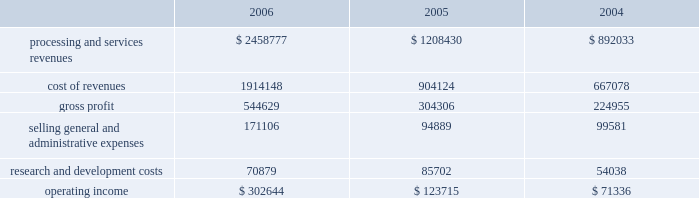Higher average borrowings .
Additionally , the recapitalization that occurred late in the first quarter of 2005 resulted in a full year of interest in 2006 as compared to approximately ten months in 2005 .
The increase in interest expense in 2005 as compared to 2004 also resulted from the recapitalization in 2005 .
Income tax expense income tax expense totaled $ 150.2 million , $ 116.1 million and $ 118.3 million for 2006 , 2005 and 2004 , respectively .
This resulted in an effective tax rate of 37.2% ( 37.2 % ) , 37.2% ( 37.2 % ) and 37.6% ( 37.6 % ) for 2006 , 2005 and 2004 , respectively .
Net earnings net earnings totaled $ 259.1 million , $ 196.6 and $ 189.4 million for 2006 , 2005 and 2004 , respectively , or $ 1.37 , $ 1.53 and $ 1.48 per diluted share , respectively .
Segment results of operations transaction processing services ( in thousands ) .
Revenues for the transaction processing services segment are derived from three main revenue channels ; enterprise solutions , integrated financial solutions and international .
Revenues from transaction processing services totaled $ 2458.8 million , $ 1208.4 and $ 892.0 million for 2006 , 2005 and 2004 , respectively .
The overall segment increase of $ 1250.4 million during 2006 , as compared to 2005 was primarily attributable to the certegy merger which contributed $ 1067.2 million to the overall increase .
The majority of the remaining 2006 growth is attributable to organic growth within the historically owned integrated financial solutions and international revenue channels , with international including $ 31.9 million related to the newly formed business process outsourcing operation in brazil .
The overall segment increase of $ 316.4 in 2005 as compared to 2004 results from the inclusion of a full year of results for the 2004 acquisitions of aurum , sanchez , kordoba , and intercept , which contributed $ 301.1 million of the increase .
Cost of revenues for the transaction processing services segment totaled $ 1914.1 million , $ 904.1 million and $ 667.1 million for 2006 , 2005 and 2004 , respectively .
The overall segment increase of $ 1010.0 million during 2006 as compared to 2005 was primarily attributable to the certegy merger which contributed $ 848.2 million to the increase .
Gross profit as a percentage of revenues ( 201cgross margin 201d ) was 22.2% ( 22.2 % ) , 25.2% ( 25.2 % ) and 25.2% ( 25.2 % ) for 2006 , 2005 and 2004 , respectively .
The decrease in gross profit in 2006 as compared to 2005 is primarily due to the february 1 , 2006 certegy merger , which businesses typically have lower margins than those of the historically owned fis businesses .
Incremental intangible asset amortization relating to the certegy merger also contributed to the decrease in gross margin .
Included in cost of revenues was depreciation and amortization of $ 272.4 million , $ 139.8 million , and $ 94.6 million for 2006 , 2005 and 2004 , respectively .
Selling , general and administrative expenses totaled $ 171.1 million , $ 94.9 million and $ 99.6 million for 2006 , 2005 and 2004 , respectively .
The increase in 2006 compared to 2005 is primarily attributable to the certegy merger which contributed $ 73.7 million to the overall increase of $ 76.2 million .
The decrease of $ 4.7 million in 2005 as compared to 2004 is primarily attributable to the effect of acquisition related costs in 2004 .
Included in selling , general and administrative expenses was depreciation and amortization of $ 11.0 million , $ 9.1 million and $ 2.3 million for 2006 , 2005 and 2004 , respectively. .
What is the net margin for 2006? 
Computations: ((259.1 * 1000) / 2458777)
Answer: 0.10538. 